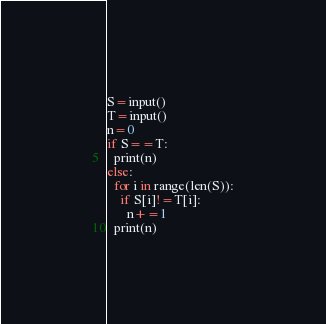<code> <loc_0><loc_0><loc_500><loc_500><_Python_>S=input()
T=input()
n=0
if S==T:
  print(n)
else:
  for i in range(len(S)):
    if S[i]!=T[i]:
      n+=1
  print(n)
</code> 